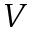Convert formula to latex. <formula><loc_0><loc_0><loc_500><loc_500>V</formula> 